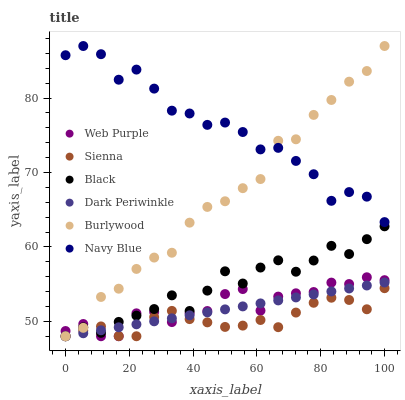Does Sienna have the minimum area under the curve?
Answer yes or no. Yes. Does Navy Blue have the maximum area under the curve?
Answer yes or no. Yes. Does Navy Blue have the minimum area under the curve?
Answer yes or no. No. Does Sienna have the maximum area under the curve?
Answer yes or no. No. Is Dark Periwinkle the smoothest?
Answer yes or no. Yes. Is Navy Blue the roughest?
Answer yes or no. Yes. Is Sienna the smoothest?
Answer yes or no. No. Is Sienna the roughest?
Answer yes or no. No. Does Burlywood have the lowest value?
Answer yes or no. Yes. Does Navy Blue have the lowest value?
Answer yes or no. No. Does Navy Blue have the highest value?
Answer yes or no. Yes. Does Sienna have the highest value?
Answer yes or no. No. Is Sienna less than Navy Blue?
Answer yes or no. Yes. Is Navy Blue greater than Sienna?
Answer yes or no. Yes. Does Burlywood intersect Navy Blue?
Answer yes or no. Yes. Is Burlywood less than Navy Blue?
Answer yes or no. No. Is Burlywood greater than Navy Blue?
Answer yes or no. No. Does Sienna intersect Navy Blue?
Answer yes or no. No. 